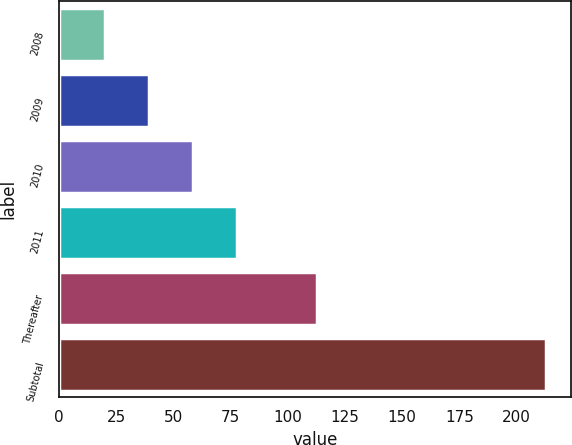Convert chart to OTSL. <chart><loc_0><loc_0><loc_500><loc_500><bar_chart><fcel>2008<fcel>2009<fcel>2010<fcel>2011<fcel>Thereafter<fcel>Subtotal<nl><fcel>20<fcel>39.3<fcel>58.6<fcel>77.9<fcel>113<fcel>213<nl></chart> 